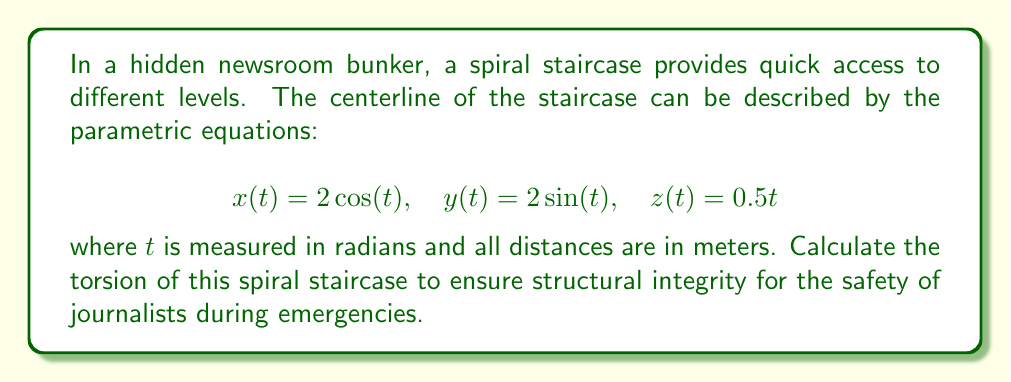Help me with this question. To compute the torsion of the spiral staircase, we'll follow these steps:

1) First, we need to calculate the first, second, and third derivatives of the position vector $\mathbf{r}(t) = (x(t), y(t), z(t))$:

   $\mathbf{r}'(t) = (-2\sin(t), 2\cos(t), 0.5)$
   $\mathbf{r}''(t) = (-2\cos(t), -2\sin(t), 0)$
   $\mathbf{r}'''(t) = (2\sin(t), -2\cos(t), 0)$

2) The torsion $\tau$ is given by the formula:

   $$\tau = \frac{(\mathbf{r}' \times \mathbf{r}'') \cdot \mathbf{r}'''}{|\mathbf{r}' \times \mathbf{r}''|^2}$$

3) Let's calculate $\mathbf{r}' \times \mathbf{r}''$:
   
   $\mathbf{r}' \times \mathbf{r}'' = \begin{vmatrix} 
   \mathbf{i} & \mathbf{j} & \mathbf{k} \\
   -2\sin(t) & 2\cos(t) & 0.5 \\
   -2\cos(t) & -2\sin(t) & 0
   \end{vmatrix}$
   
   $= (-\sin(t), -\cos(t), -4)$

4) Now, let's compute $(\mathbf{r}' \times \mathbf{r}'') \cdot \mathbf{r}'''$:

   $(-\sin(t), -\cos(t), -4) \cdot (2\sin(t), -2\cos(t), 0) = -2\sin^2(t) + 2\cos^2(t) = 2\cos(2t)$

5) Next, we calculate $|\mathbf{r}' \times \mathbf{r}''|^2$:

   $|-\sin(t)\mathbf{i} - \cos(t)\mathbf{j} - 4\mathbf{k}|^2 = \sin^2(t) + \cos^2(t) + 16 = 17$

6) Finally, we can compute the torsion:

   $$\tau = \frac{2\cos(2t)}{17} = \frac{2}{17}\cos(2t)$$

This is a constant value, independent of $t$.
Answer: $\tau = \frac{2}{17}\cos(2t)$ 